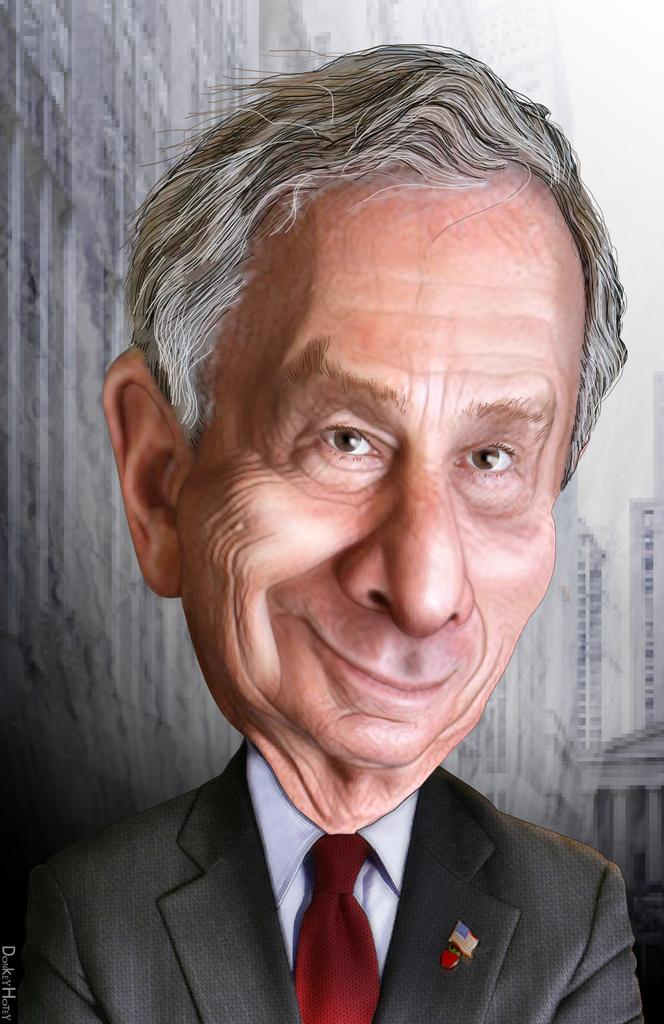Who or what is the main subject in the image? There is a person in the image. Can you describe the person's attire? The person is wearing a coat and tie. What can be seen in the background of the image? There is a group of buildings and the sky visible in the background of the image. Is there any text present in the image? Yes, there is some text in the image. How many kittens are playing with the person's tie in the image? There are no kittens present in the image, so they cannot be playing with the person's tie. What type of laborer is the person in the image? The facts provided do not mention the person's occupation, so we cannot determine if they are a laborer or not. --- Facts: 1. There is a car in the image. 2. The car is red. 3. The car has four wheels. 4. There is a road in the image. 5. The road is paved. Absurd Topics: bird, ocean, mountain Conversation: What is the main subject in the image? There is a car in the image. Can you describe the car's color? The car is red. How many wheels does the car have? The car has four wheels. What type of surface is the car on in the image? There is a road in the image, and it is paved. Reasoning: Let's think step by step in order to produce the conversation. We start by identifying the main subject in the image, which is the car. Then, we describe the car's color and the number of wheels it has. Next, we expand the conversation to include the road in the image, noting that it is paved. Absurd Question/Answer: Can you see any birds flying over the ocean in the image? There is no ocean or birds present in the image; it features a red car on a paved road. What type of mountain range is visible in the background of the image? There is no mountain range present in the image; it features a red car on a paved road. 